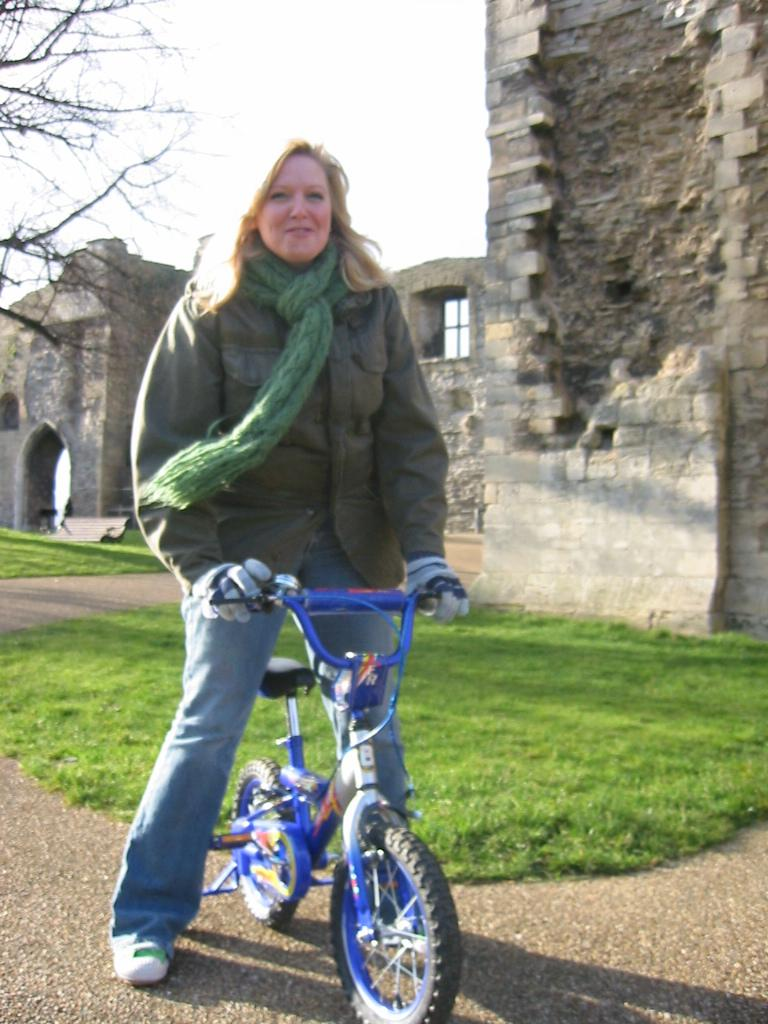What is the woman in the image doing? The woman is standing in the image and holding a bicycle. What type of surface is visible beneath the woman's feet? There is grass visible in the image. What can be seen in the background of the image? There is a wall, a window, and the sky visible in the background of the image. How many times does the woman's head quiver in the image? There is no indication in the image that the woman's head is quivering, so it cannot be determined. 